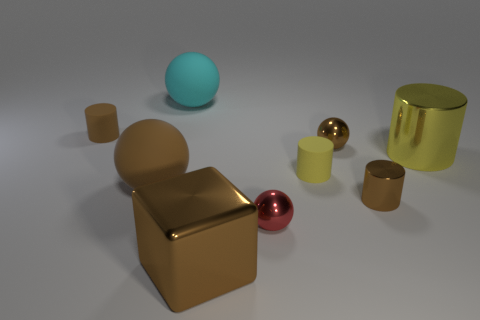Subtract all brown rubber cylinders. How many cylinders are left? 3 Subtract all gray blocks. How many brown cylinders are left? 2 Add 1 tiny brown metallic cylinders. How many objects exist? 10 Subtract all brown spheres. How many spheres are left? 2 Subtract all cylinders. How many objects are left? 5 Subtract 2 cylinders. How many cylinders are left? 2 Add 6 brown metal balls. How many brown metal balls are left? 7 Add 5 tiny cylinders. How many tiny cylinders exist? 8 Subtract 1 yellow cylinders. How many objects are left? 8 Subtract all cyan cubes. Subtract all gray balls. How many cubes are left? 1 